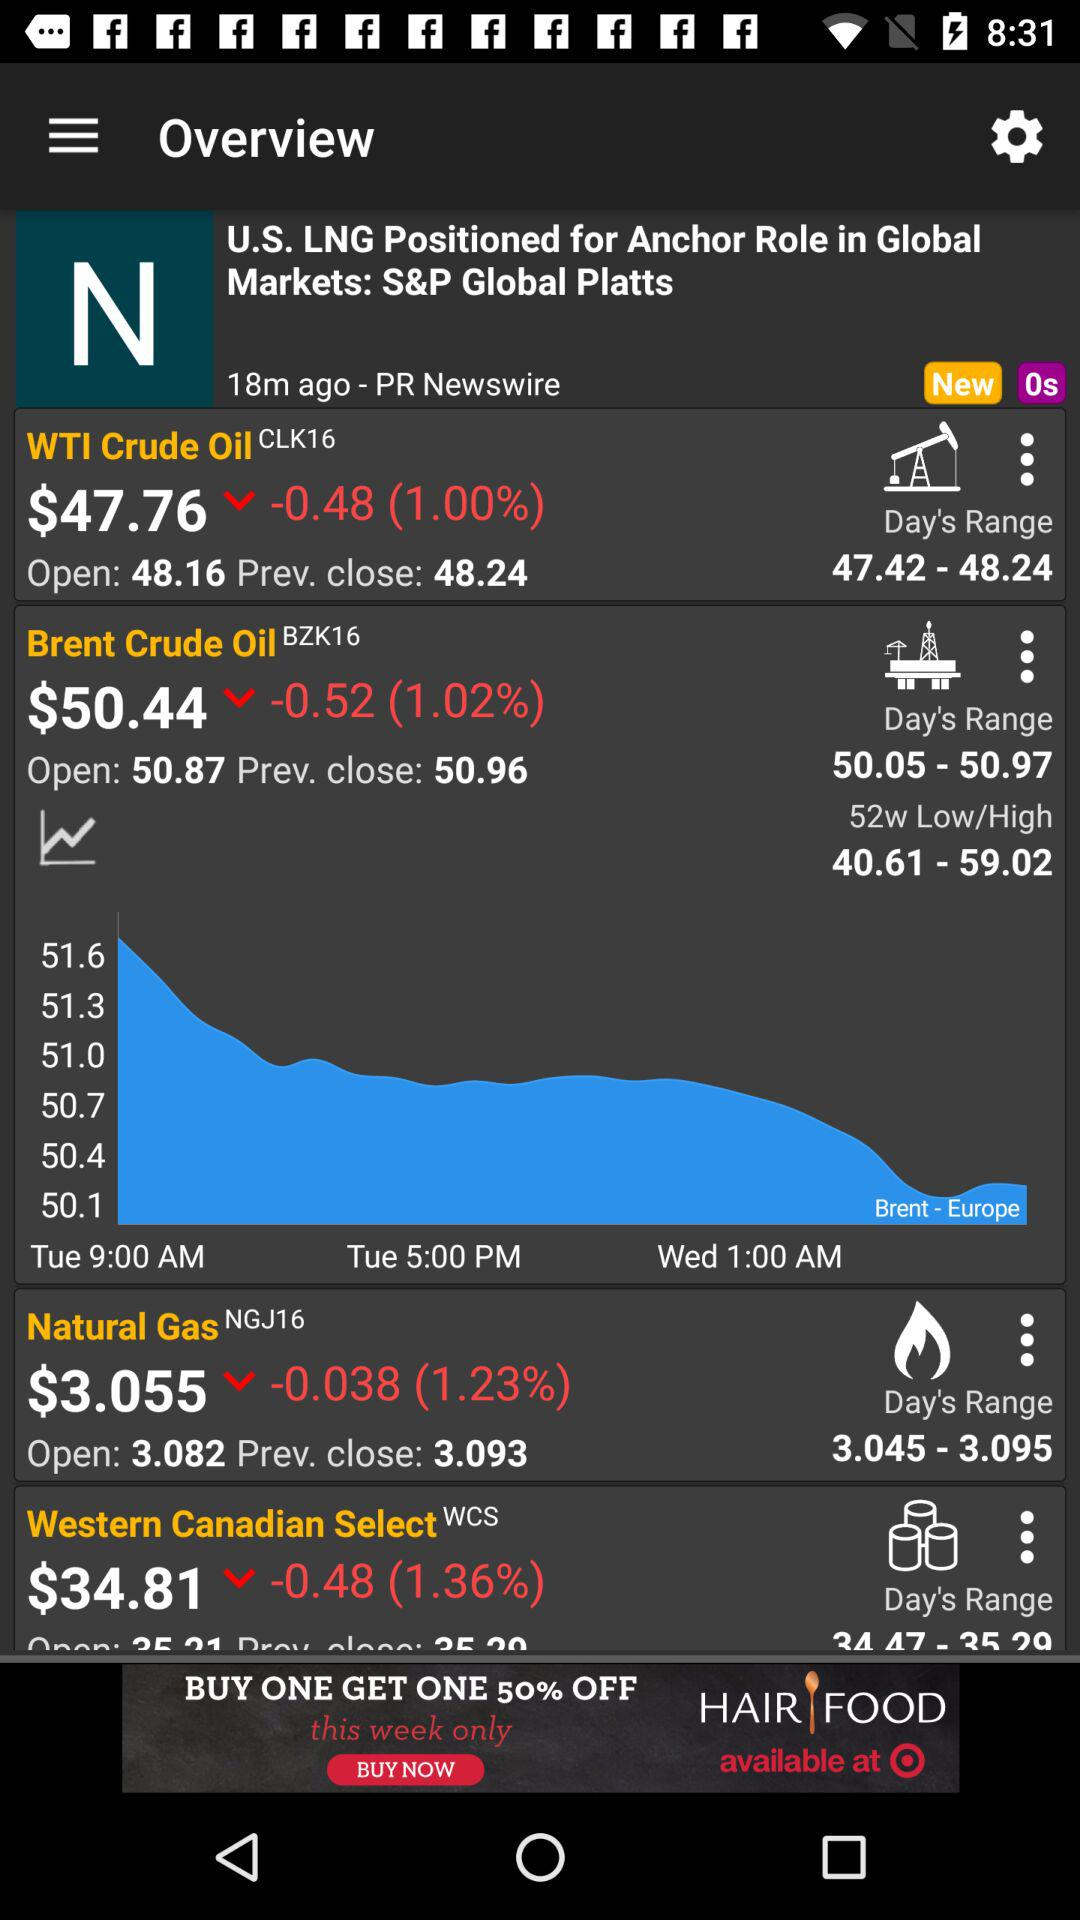What is the currency of price? The currency is dollars. 